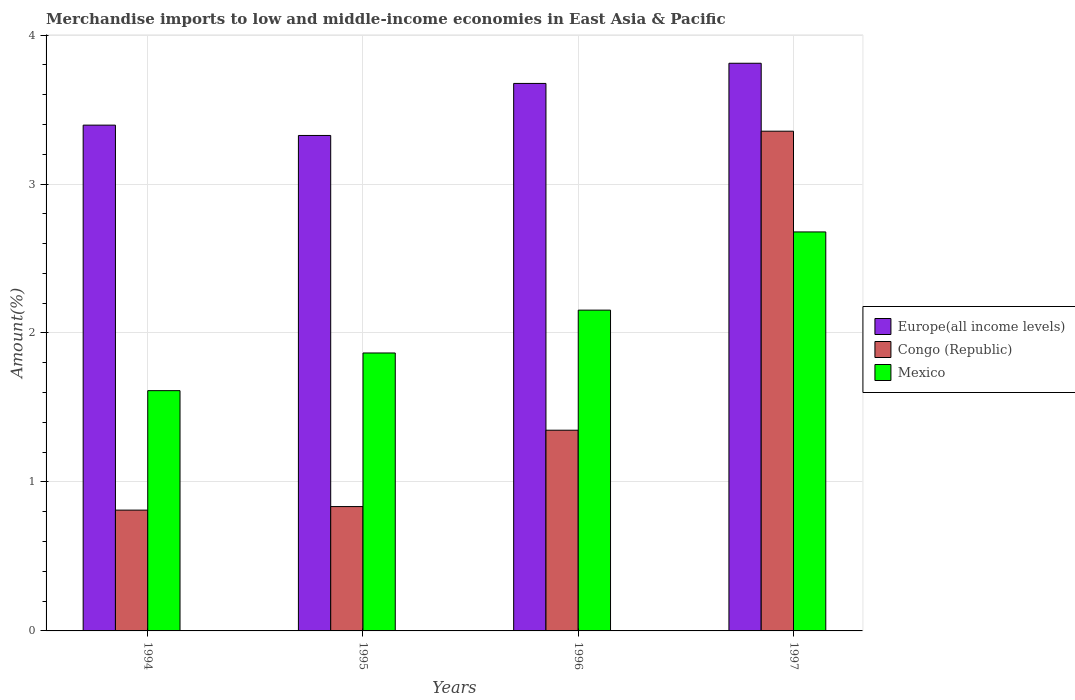How many different coloured bars are there?
Your response must be concise. 3. How many groups of bars are there?
Your answer should be compact. 4. Are the number of bars on each tick of the X-axis equal?
Offer a very short reply. Yes. How many bars are there on the 4th tick from the left?
Give a very brief answer. 3. What is the label of the 4th group of bars from the left?
Your answer should be very brief. 1997. In how many cases, is the number of bars for a given year not equal to the number of legend labels?
Your answer should be very brief. 0. What is the percentage of amount earned from merchandise imports in Mexico in 1996?
Keep it short and to the point. 2.15. Across all years, what is the maximum percentage of amount earned from merchandise imports in Congo (Republic)?
Offer a very short reply. 3.35. Across all years, what is the minimum percentage of amount earned from merchandise imports in Europe(all income levels)?
Your response must be concise. 3.33. In which year was the percentage of amount earned from merchandise imports in Europe(all income levels) maximum?
Your answer should be compact. 1997. What is the total percentage of amount earned from merchandise imports in Mexico in the graph?
Ensure brevity in your answer.  8.31. What is the difference between the percentage of amount earned from merchandise imports in Europe(all income levels) in 1994 and that in 1995?
Offer a very short reply. 0.07. What is the difference between the percentage of amount earned from merchandise imports in Europe(all income levels) in 1997 and the percentage of amount earned from merchandise imports in Congo (Republic) in 1996?
Give a very brief answer. 2.46. What is the average percentage of amount earned from merchandise imports in Europe(all income levels) per year?
Provide a succinct answer. 3.55. In the year 1995, what is the difference between the percentage of amount earned from merchandise imports in Congo (Republic) and percentage of amount earned from merchandise imports in Mexico?
Provide a short and direct response. -1.03. In how many years, is the percentage of amount earned from merchandise imports in Mexico greater than 0.4 %?
Offer a terse response. 4. What is the ratio of the percentage of amount earned from merchandise imports in Congo (Republic) in 1995 to that in 1997?
Provide a short and direct response. 0.25. What is the difference between the highest and the second highest percentage of amount earned from merchandise imports in Mexico?
Ensure brevity in your answer.  0.52. What is the difference between the highest and the lowest percentage of amount earned from merchandise imports in Europe(all income levels)?
Your answer should be compact. 0.48. What does the 2nd bar from the right in 1997 represents?
Keep it short and to the point. Congo (Republic). How many bars are there?
Ensure brevity in your answer.  12. Are all the bars in the graph horizontal?
Keep it short and to the point. No. What is the difference between two consecutive major ticks on the Y-axis?
Offer a very short reply. 1. Does the graph contain any zero values?
Keep it short and to the point. No. Does the graph contain grids?
Make the answer very short. Yes. What is the title of the graph?
Your answer should be very brief. Merchandise imports to low and middle-income economies in East Asia & Pacific. What is the label or title of the Y-axis?
Provide a succinct answer. Amount(%). What is the Amount(%) in Europe(all income levels) in 1994?
Provide a short and direct response. 3.4. What is the Amount(%) in Congo (Republic) in 1994?
Provide a short and direct response. 0.81. What is the Amount(%) of Mexico in 1994?
Provide a short and direct response. 1.61. What is the Amount(%) of Europe(all income levels) in 1995?
Provide a succinct answer. 3.33. What is the Amount(%) of Congo (Republic) in 1995?
Provide a succinct answer. 0.83. What is the Amount(%) of Mexico in 1995?
Give a very brief answer. 1.87. What is the Amount(%) in Europe(all income levels) in 1996?
Offer a terse response. 3.68. What is the Amount(%) in Congo (Republic) in 1996?
Make the answer very short. 1.35. What is the Amount(%) in Mexico in 1996?
Give a very brief answer. 2.15. What is the Amount(%) of Europe(all income levels) in 1997?
Your response must be concise. 3.81. What is the Amount(%) of Congo (Republic) in 1997?
Your answer should be compact. 3.35. What is the Amount(%) of Mexico in 1997?
Give a very brief answer. 2.68. Across all years, what is the maximum Amount(%) of Europe(all income levels)?
Keep it short and to the point. 3.81. Across all years, what is the maximum Amount(%) of Congo (Republic)?
Ensure brevity in your answer.  3.35. Across all years, what is the maximum Amount(%) of Mexico?
Your answer should be compact. 2.68. Across all years, what is the minimum Amount(%) of Europe(all income levels)?
Give a very brief answer. 3.33. Across all years, what is the minimum Amount(%) of Congo (Republic)?
Offer a very short reply. 0.81. Across all years, what is the minimum Amount(%) of Mexico?
Provide a succinct answer. 1.61. What is the total Amount(%) of Europe(all income levels) in the graph?
Provide a succinct answer. 14.21. What is the total Amount(%) in Congo (Republic) in the graph?
Your answer should be compact. 6.35. What is the total Amount(%) in Mexico in the graph?
Ensure brevity in your answer.  8.31. What is the difference between the Amount(%) of Europe(all income levels) in 1994 and that in 1995?
Ensure brevity in your answer.  0.07. What is the difference between the Amount(%) in Congo (Republic) in 1994 and that in 1995?
Your answer should be very brief. -0.02. What is the difference between the Amount(%) of Mexico in 1994 and that in 1995?
Offer a very short reply. -0.25. What is the difference between the Amount(%) in Europe(all income levels) in 1994 and that in 1996?
Keep it short and to the point. -0.28. What is the difference between the Amount(%) in Congo (Republic) in 1994 and that in 1996?
Your answer should be compact. -0.54. What is the difference between the Amount(%) of Mexico in 1994 and that in 1996?
Provide a succinct answer. -0.54. What is the difference between the Amount(%) in Europe(all income levels) in 1994 and that in 1997?
Make the answer very short. -0.42. What is the difference between the Amount(%) in Congo (Republic) in 1994 and that in 1997?
Offer a very short reply. -2.54. What is the difference between the Amount(%) of Mexico in 1994 and that in 1997?
Give a very brief answer. -1.07. What is the difference between the Amount(%) in Europe(all income levels) in 1995 and that in 1996?
Give a very brief answer. -0.35. What is the difference between the Amount(%) of Congo (Republic) in 1995 and that in 1996?
Give a very brief answer. -0.51. What is the difference between the Amount(%) of Mexico in 1995 and that in 1996?
Your answer should be compact. -0.29. What is the difference between the Amount(%) in Europe(all income levels) in 1995 and that in 1997?
Make the answer very short. -0.48. What is the difference between the Amount(%) in Congo (Republic) in 1995 and that in 1997?
Ensure brevity in your answer.  -2.52. What is the difference between the Amount(%) of Mexico in 1995 and that in 1997?
Your answer should be very brief. -0.81. What is the difference between the Amount(%) of Europe(all income levels) in 1996 and that in 1997?
Your answer should be compact. -0.14. What is the difference between the Amount(%) in Congo (Republic) in 1996 and that in 1997?
Provide a succinct answer. -2.01. What is the difference between the Amount(%) of Mexico in 1996 and that in 1997?
Keep it short and to the point. -0.53. What is the difference between the Amount(%) of Europe(all income levels) in 1994 and the Amount(%) of Congo (Republic) in 1995?
Your answer should be very brief. 2.56. What is the difference between the Amount(%) of Europe(all income levels) in 1994 and the Amount(%) of Mexico in 1995?
Offer a very short reply. 1.53. What is the difference between the Amount(%) of Congo (Republic) in 1994 and the Amount(%) of Mexico in 1995?
Your answer should be very brief. -1.05. What is the difference between the Amount(%) of Europe(all income levels) in 1994 and the Amount(%) of Congo (Republic) in 1996?
Give a very brief answer. 2.05. What is the difference between the Amount(%) in Europe(all income levels) in 1994 and the Amount(%) in Mexico in 1996?
Provide a short and direct response. 1.24. What is the difference between the Amount(%) in Congo (Republic) in 1994 and the Amount(%) in Mexico in 1996?
Ensure brevity in your answer.  -1.34. What is the difference between the Amount(%) in Europe(all income levels) in 1994 and the Amount(%) in Congo (Republic) in 1997?
Keep it short and to the point. 0.04. What is the difference between the Amount(%) of Europe(all income levels) in 1994 and the Amount(%) of Mexico in 1997?
Make the answer very short. 0.72. What is the difference between the Amount(%) of Congo (Republic) in 1994 and the Amount(%) of Mexico in 1997?
Your answer should be compact. -1.87. What is the difference between the Amount(%) in Europe(all income levels) in 1995 and the Amount(%) in Congo (Republic) in 1996?
Ensure brevity in your answer.  1.98. What is the difference between the Amount(%) of Europe(all income levels) in 1995 and the Amount(%) of Mexico in 1996?
Give a very brief answer. 1.17. What is the difference between the Amount(%) of Congo (Republic) in 1995 and the Amount(%) of Mexico in 1996?
Make the answer very short. -1.32. What is the difference between the Amount(%) of Europe(all income levels) in 1995 and the Amount(%) of Congo (Republic) in 1997?
Ensure brevity in your answer.  -0.03. What is the difference between the Amount(%) in Europe(all income levels) in 1995 and the Amount(%) in Mexico in 1997?
Your answer should be very brief. 0.65. What is the difference between the Amount(%) in Congo (Republic) in 1995 and the Amount(%) in Mexico in 1997?
Make the answer very short. -1.84. What is the difference between the Amount(%) in Europe(all income levels) in 1996 and the Amount(%) in Congo (Republic) in 1997?
Keep it short and to the point. 0.32. What is the difference between the Amount(%) of Congo (Republic) in 1996 and the Amount(%) of Mexico in 1997?
Provide a short and direct response. -1.33. What is the average Amount(%) in Europe(all income levels) per year?
Provide a succinct answer. 3.55. What is the average Amount(%) of Congo (Republic) per year?
Your response must be concise. 1.59. What is the average Amount(%) in Mexico per year?
Your response must be concise. 2.08. In the year 1994, what is the difference between the Amount(%) of Europe(all income levels) and Amount(%) of Congo (Republic)?
Offer a very short reply. 2.58. In the year 1994, what is the difference between the Amount(%) of Europe(all income levels) and Amount(%) of Mexico?
Give a very brief answer. 1.78. In the year 1994, what is the difference between the Amount(%) of Congo (Republic) and Amount(%) of Mexico?
Your answer should be very brief. -0.8. In the year 1995, what is the difference between the Amount(%) of Europe(all income levels) and Amount(%) of Congo (Republic)?
Provide a short and direct response. 2.49. In the year 1995, what is the difference between the Amount(%) of Europe(all income levels) and Amount(%) of Mexico?
Your answer should be compact. 1.46. In the year 1995, what is the difference between the Amount(%) in Congo (Republic) and Amount(%) in Mexico?
Give a very brief answer. -1.03. In the year 1996, what is the difference between the Amount(%) of Europe(all income levels) and Amount(%) of Congo (Republic)?
Your answer should be compact. 2.33. In the year 1996, what is the difference between the Amount(%) in Europe(all income levels) and Amount(%) in Mexico?
Your answer should be compact. 1.52. In the year 1996, what is the difference between the Amount(%) of Congo (Republic) and Amount(%) of Mexico?
Your answer should be compact. -0.81. In the year 1997, what is the difference between the Amount(%) of Europe(all income levels) and Amount(%) of Congo (Republic)?
Provide a succinct answer. 0.46. In the year 1997, what is the difference between the Amount(%) in Europe(all income levels) and Amount(%) in Mexico?
Your response must be concise. 1.13. In the year 1997, what is the difference between the Amount(%) of Congo (Republic) and Amount(%) of Mexico?
Your answer should be very brief. 0.68. What is the ratio of the Amount(%) in Europe(all income levels) in 1994 to that in 1995?
Give a very brief answer. 1.02. What is the ratio of the Amount(%) of Congo (Republic) in 1994 to that in 1995?
Offer a very short reply. 0.97. What is the ratio of the Amount(%) in Mexico in 1994 to that in 1995?
Ensure brevity in your answer.  0.86. What is the ratio of the Amount(%) in Europe(all income levels) in 1994 to that in 1996?
Offer a very short reply. 0.92. What is the ratio of the Amount(%) in Congo (Republic) in 1994 to that in 1996?
Provide a succinct answer. 0.6. What is the ratio of the Amount(%) of Mexico in 1994 to that in 1996?
Your answer should be very brief. 0.75. What is the ratio of the Amount(%) of Europe(all income levels) in 1994 to that in 1997?
Ensure brevity in your answer.  0.89. What is the ratio of the Amount(%) of Congo (Republic) in 1994 to that in 1997?
Offer a terse response. 0.24. What is the ratio of the Amount(%) in Mexico in 1994 to that in 1997?
Ensure brevity in your answer.  0.6. What is the ratio of the Amount(%) of Europe(all income levels) in 1995 to that in 1996?
Offer a terse response. 0.91. What is the ratio of the Amount(%) in Congo (Republic) in 1995 to that in 1996?
Offer a terse response. 0.62. What is the ratio of the Amount(%) in Mexico in 1995 to that in 1996?
Offer a very short reply. 0.87. What is the ratio of the Amount(%) in Europe(all income levels) in 1995 to that in 1997?
Ensure brevity in your answer.  0.87. What is the ratio of the Amount(%) of Congo (Republic) in 1995 to that in 1997?
Provide a succinct answer. 0.25. What is the ratio of the Amount(%) of Mexico in 1995 to that in 1997?
Your answer should be very brief. 0.7. What is the ratio of the Amount(%) in Europe(all income levels) in 1996 to that in 1997?
Offer a terse response. 0.96. What is the ratio of the Amount(%) in Congo (Republic) in 1996 to that in 1997?
Provide a short and direct response. 0.4. What is the ratio of the Amount(%) in Mexico in 1996 to that in 1997?
Your response must be concise. 0.8. What is the difference between the highest and the second highest Amount(%) in Europe(all income levels)?
Give a very brief answer. 0.14. What is the difference between the highest and the second highest Amount(%) in Congo (Republic)?
Give a very brief answer. 2.01. What is the difference between the highest and the second highest Amount(%) of Mexico?
Provide a short and direct response. 0.53. What is the difference between the highest and the lowest Amount(%) in Europe(all income levels)?
Make the answer very short. 0.48. What is the difference between the highest and the lowest Amount(%) in Congo (Republic)?
Provide a succinct answer. 2.54. What is the difference between the highest and the lowest Amount(%) of Mexico?
Your answer should be very brief. 1.07. 